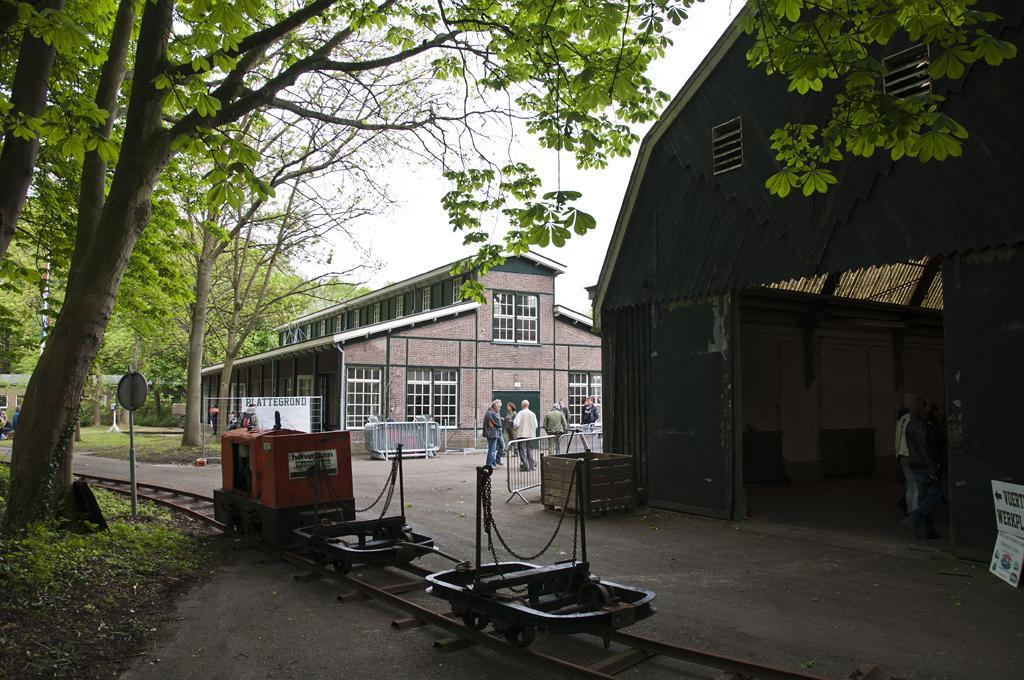In one or two sentences, can you explain what this image depicts? In this image I can see few buildings, windows, shed, trees, few people and few objects around. I can see the sign boards, poles, sky and few objects on the track. 